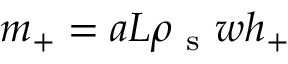Convert formula to latex. <formula><loc_0><loc_0><loc_500><loc_500>m _ { + } = a L \rho _ { s } w h _ { + }</formula> 